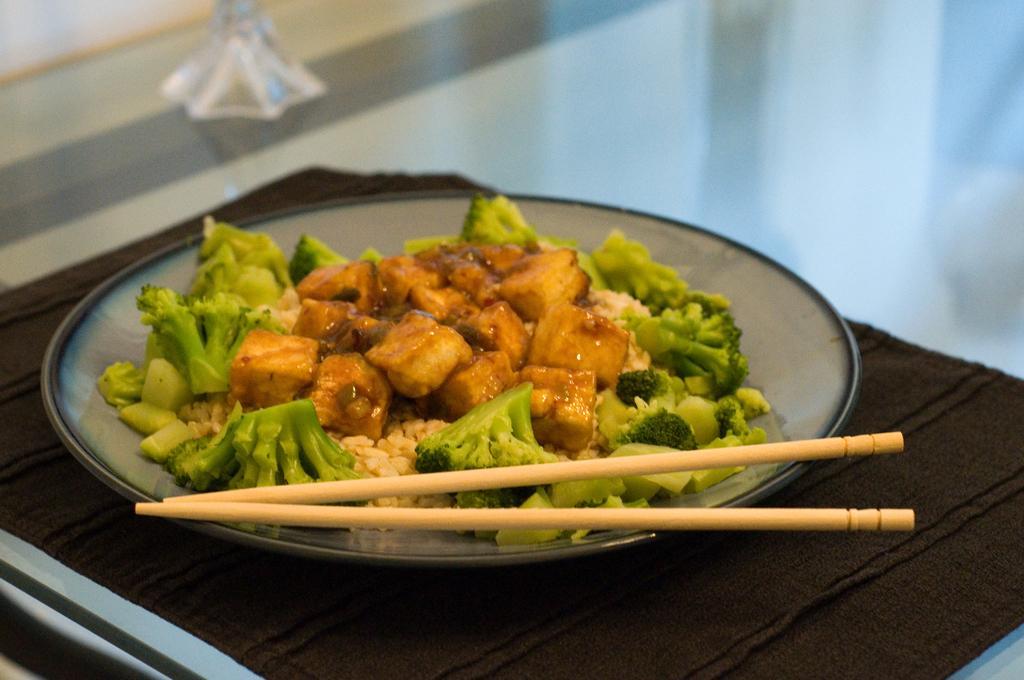Please provide a concise description of this image. In this image there is a plate and in the plate there is some food, and there are chopsticks. At the bottom there is a cloth, and in the background there might be a table and some object. 